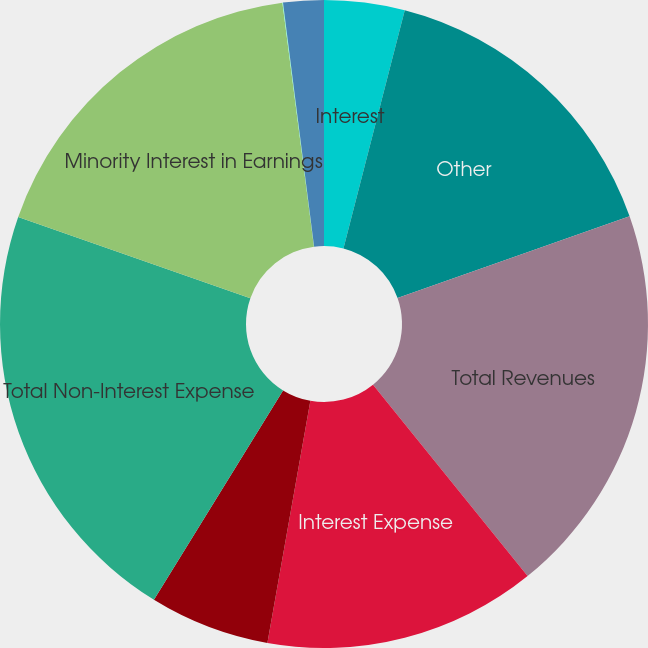Convert chart to OTSL. <chart><loc_0><loc_0><loc_500><loc_500><pie_chart><fcel>Interest<fcel>Other<fcel>Total Revenues<fcel>Interest Expense<fcel>Net Revenues<fcel>Total Non-Interest Expense<fcel>Minority Interest in Earnings<fcel>Income Before Provision for<fcel>Net (Loss) Income<nl><fcel>4.01%<fcel>15.6%<fcel>19.58%<fcel>13.61%<fcel>6.0%<fcel>21.57%<fcel>17.59%<fcel>0.03%<fcel>2.02%<nl></chart> 